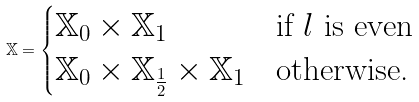<formula> <loc_0><loc_0><loc_500><loc_500>\mathbb { X } = \begin{cases} \mathbb { X } _ { 0 } \times \mathbb { X } _ { 1 } & \text {if } l \text { is even} \\ \mathbb { X } _ { 0 } \times \mathbb { X } _ { \frac { 1 } { 2 } } \times \mathbb { X } _ { 1 } & \text {otherwise.} \end{cases}</formula> 